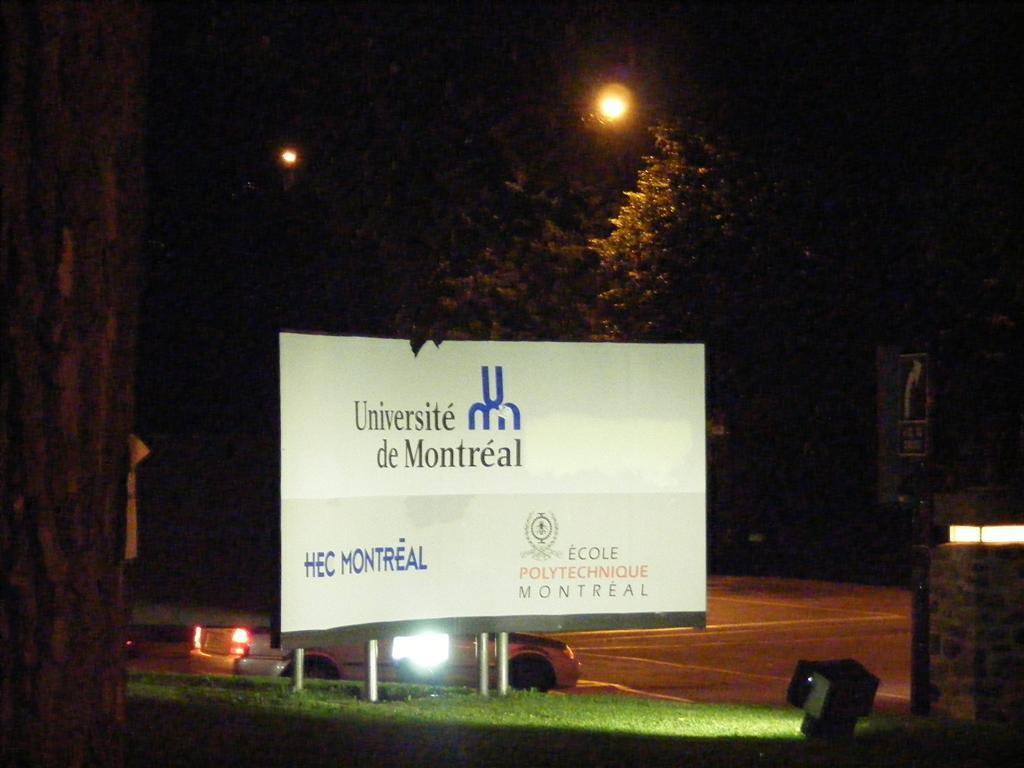Where is this university?
Your response must be concise. Montreal. 